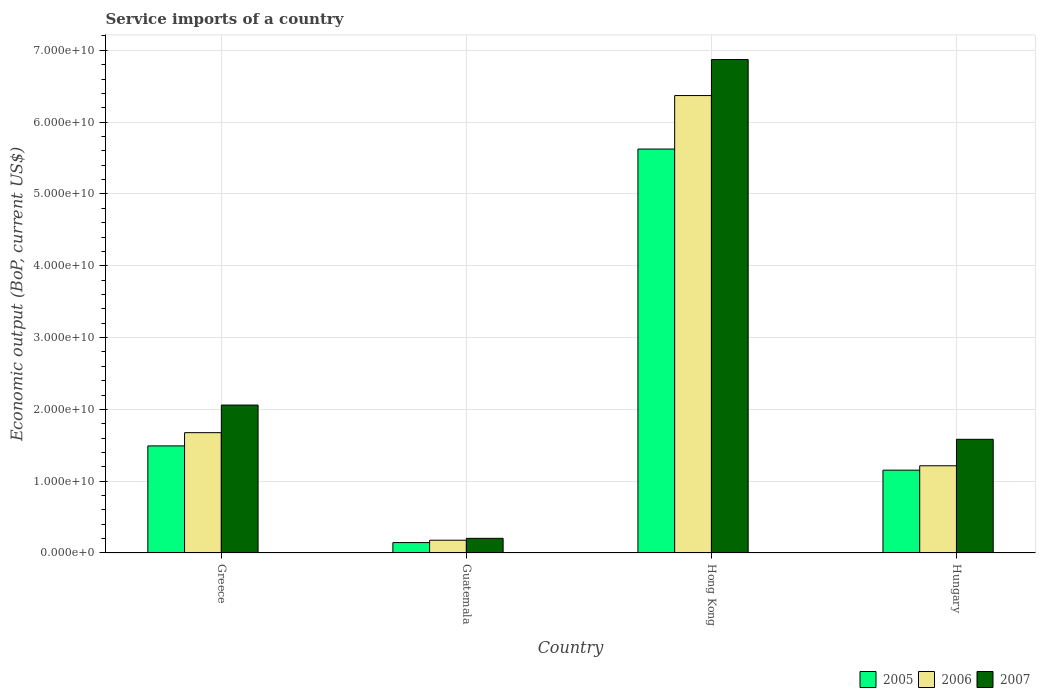Are the number of bars per tick equal to the number of legend labels?
Provide a short and direct response. Yes. Are the number of bars on each tick of the X-axis equal?
Make the answer very short. Yes. How many bars are there on the 4th tick from the left?
Ensure brevity in your answer.  3. In how many cases, is the number of bars for a given country not equal to the number of legend labels?
Offer a very short reply. 0. What is the service imports in 2006 in Hong Kong?
Make the answer very short. 6.37e+1. Across all countries, what is the maximum service imports in 2007?
Keep it short and to the point. 6.87e+1. Across all countries, what is the minimum service imports in 2005?
Provide a succinct answer. 1.45e+09. In which country was the service imports in 2007 maximum?
Offer a terse response. Hong Kong. In which country was the service imports in 2005 minimum?
Provide a succinct answer. Guatemala. What is the total service imports in 2005 in the graph?
Make the answer very short. 8.42e+1. What is the difference between the service imports in 2007 in Greece and that in Guatemala?
Provide a short and direct response. 1.86e+1. What is the difference between the service imports in 2005 in Guatemala and the service imports in 2007 in Hungary?
Offer a very short reply. -1.44e+1. What is the average service imports in 2005 per country?
Your answer should be very brief. 2.10e+1. What is the difference between the service imports of/in 2005 and service imports of/in 2007 in Guatemala?
Offer a very short reply. -5.92e+08. What is the ratio of the service imports in 2007 in Greece to that in Hong Kong?
Offer a very short reply. 0.3. Is the service imports in 2005 in Greece less than that in Hong Kong?
Give a very brief answer. Yes. Is the difference between the service imports in 2005 in Greece and Hong Kong greater than the difference between the service imports in 2007 in Greece and Hong Kong?
Keep it short and to the point. Yes. What is the difference between the highest and the second highest service imports in 2006?
Ensure brevity in your answer.  4.69e+1. What is the difference between the highest and the lowest service imports in 2005?
Your answer should be very brief. 5.48e+1. Is the sum of the service imports in 2007 in Hong Kong and Hungary greater than the maximum service imports in 2005 across all countries?
Give a very brief answer. Yes. What does the 3rd bar from the left in Greece represents?
Provide a short and direct response. 2007. Is it the case that in every country, the sum of the service imports in 2006 and service imports in 2005 is greater than the service imports in 2007?
Make the answer very short. Yes. How many bars are there?
Offer a terse response. 12. Are all the bars in the graph horizontal?
Offer a very short reply. No. How many countries are there in the graph?
Your answer should be very brief. 4. Does the graph contain any zero values?
Keep it short and to the point. No. What is the title of the graph?
Provide a short and direct response. Service imports of a country. Does "2009" appear as one of the legend labels in the graph?
Keep it short and to the point. No. What is the label or title of the Y-axis?
Keep it short and to the point. Economic output (BoP, current US$). What is the Economic output (BoP, current US$) of 2005 in Greece?
Provide a short and direct response. 1.49e+1. What is the Economic output (BoP, current US$) in 2006 in Greece?
Ensure brevity in your answer.  1.68e+1. What is the Economic output (BoP, current US$) in 2007 in Greece?
Provide a short and direct response. 2.06e+1. What is the Economic output (BoP, current US$) in 2005 in Guatemala?
Make the answer very short. 1.45e+09. What is the Economic output (BoP, current US$) of 2006 in Guatemala?
Ensure brevity in your answer.  1.78e+09. What is the Economic output (BoP, current US$) of 2007 in Guatemala?
Your response must be concise. 2.04e+09. What is the Economic output (BoP, current US$) of 2005 in Hong Kong?
Keep it short and to the point. 5.63e+1. What is the Economic output (BoP, current US$) in 2006 in Hong Kong?
Keep it short and to the point. 6.37e+1. What is the Economic output (BoP, current US$) of 2007 in Hong Kong?
Give a very brief answer. 6.87e+1. What is the Economic output (BoP, current US$) in 2005 in Hungary?
Make the answer very short. 1.15e+1. What is the Economic output (BoP, current US$) of 2006 in Hungary?
Offer a very short reply. 1.21e+1. What is the Economic output (BoP, current US$) of 2007 in Hungary?
Your answer should be compact. 1.58e+1. Across all countries, what is the maximum Economic output (BoP, current US$) of 2005?
Give a very brief answer. 5.63e+1. Across all countries, what is the maximum Economic output (BoP, current US$) in 2006?
Offer a very short reply. 6.37e+1. Across all countries, what is the maximum Economic output (BoP, current US$) in 2007?
Your response must be concise. 6.87e+1. Across all countries, what is the minimum Economic output (BoP, current US$) of 2005?
Your answer should be compact. 1.45e+09. Across all countries, what is the minimum Economic output (BoP, current US$) of 2006?
Ensure brevity in your answer.  1.78e+09. Across all countries, what is the minimum Economic output (BoP, current US$) of 2007?
Give a very brief answer. 2.04e+09. What is the total Economic output (BoP, current US$) of 2005 in the graph?
Make the answer very short. 8.42e+1. What is the total Economic output (BoP, current US$) of 2006 in the graph?
Provide a succinct answer. 9.44e+1. What is the total Economic output (BoP, current US$) in 2007 in the graph?
Your answer should be compact. 1.07e+11. What is the difference between the Economic output (BoP, current US$) in 2005 in Greece and that in Guatemala?
Offer a very short reply. 1.35e+1. What is the difference between the Economic output (BoP, current US$) in 2006 in Greece and that in Guatemala?
Your response must be concise. 1.50e+1. What is the difference between the Economic output (BoP, current US$) in 2007 in Greece and that in Guatemala?
Make the answer very short. 1.86e+1. What is the difference between the Economic output (BoP, current US$) of 2005 in Greece and that in Hong Kong?
Ensure brevity in your answer.  -4.13e+1. What is the difference between the Economic output (BoP, current US$) of 2006 in Greece and that in Hong Kong?
Ensure brevity in your answer.  -4.69e+1. What is the difference between the Economic output (BoP, current US$) of 2007 in Greece and that in Hong Kong?
Give a very brief answer. -4.81e+1. What is the difference between the Economic output (BoP, current US$) in 2005 in Greece and that in Hungary?
Keep it short and to the point. 3.38e+09. What is the difference between the Economic output (BoP, current US$) of 2006 in Greece and that in Hungary?
Offer a very short reply. 4.61e+09. What is the difference between the Economic output (BoP, current US$) in 2007 in Greece and that in Hungary?
Offer a very short reply. 4.77e+09. What is the difference between the Economic output (BoP, current US$) of 2005 in Guatemala and that in Hong Kong?
Give a very brief answer. -5.48e+1. What is the difference between the Economic output (BoP, current US$) in 2006 in Guatemala and that in Hong Kong?
Keep it short and to the point. -6.19e+1. What is the difference between the Economic output (BoP, current US$) of 2007 in Guatemala and that in Hong Kong?
Your answer should be very brief. -6.67e+1. What is the difference between the Economic output (BoP, current US$) of 2005 in Guatemala and that in Hungary?
Provide a short and direct response. -1.01e+1. What is the difference between the Economic output (BoP, current US$) of 2006 in Guatemala and that in Hungary?
Your answer should be very brief. -1.04e+1. What is the difference between the Economic output (BoP, current US$) of 2007 in Guatemala and that in Hungary?
Offer a very short reply. -1.38e+1. What is the difference between the Economic output (BoP, current US$) in 2005 in Hong Kong and that in Hungary?
Offer a very short reply. 4.47e+1. What is the difference between the Economic output (BoP, current US$) in 2006 in Hong Kong and that in Hungary?
Your answer should be compact. 5.16e+1. What is the difference between the Economic output (BoP, current US$) of 2007 in Hong Kong and that in Hungary?
Provide a short and direct response. 5.29e+1. What is the difference between the Economic output (BoP, current US$) of 2005 in Greece and the Economic output (BoP, current US$) of 2006 in Guatemala?
Provide a short and direct response. 1.31e+1. What is the difference between the Economic output (BoP, current US$) of 2005 in Greece and the Economic output (BoP, current US$) of 2007 in Guatemala?
Give a very brief answer. 1.29e+1. What is the difference between the Economic output (BoP, current US$) in 2006 in Greece and the Economic output (BoP, current US$) in 2007 in Guatemala?
Your answer should be very brief. 1.47e+1. What is the difference between the Economic output (BoP, current US$) of 2005 in Greece and the Economic output (BoP, current US$) of 2006 in Hong Kong?
Ensure brevity in your answer.  -4.88e+1. What is the difference between the Economic output (BoP, current US$) of 2005 in Greece and the Economic output (BoP, current US$) of 2007 in Hong Kong?
Keep it short and to the point. -5.38e+1. What is the difference between the Economic output (BoP, current US$) of 2006 in Greece and the Economic output (BoP, current US$) of 2007 in Hong Kong?
Offer a terse response. -5.20e+1. What is the difference between the Economic output (BoP, current US$) of 2005 in Greece and the Economic output (BoP, current US$) of 2006 in Hungary?
Your response must be concise. 2.77e+09. What is the difference between the Economic output (BoP, current US$) of 2005 in Greece and the Economic output (BoP, current US$) of 2007 in Hungary?
Offer a very short reply. -9.18e+08. What is the difference between the Economic output (BoP, current US$) in 2006 in Greece and the Economic output (BoP, current US$) in 2007 in Hungary?
Offer a terse response. 9.25e+08. What is the difference between the Economic output (BoP, current US$) in 2005 in Guatemala and the Economic output (BoP, current US$) in 2006 in Hong Kong?
Your answer should be compact. -6.23e+1. What is the difference between the Economic output (BoP, current US$) in 2005 in Guatemala and the Economic output (BoP, current US$) in 2007 in Hong Kong?
Offer a very short reply. -6.73e+1. What is the difference between the Economic output (BoP, current US$) of 2006 in Guatemala and the Economic output (BoP, current US$) of 2007 in Hong Kong?
Make the answer very short. -6.69e+1. What is the difference between the Economic output (BoP, current US$) in 2005 in Guatemala and the Economic output (BoP, current US$) in 2006 in Hungary?
Provide a succinct answer. -1.07e+1. What is the difference between the Economic output (BoP, current US$) of 2005 in Guatemala and the Economic output (BoP, current US$) of 2007 in Hungary?
Provide a short and direct response. -1.44e+1. What is the difference between the Economic output (BoP, current US$) in 2006 in Guatemala and the Economic output (BoP, current US$) in 2007 in Hungary?
Your answer should be compact. -1.41e+1. What is the difference between the Economic output (BoP, current US$) in 2005 in Hong Kong and the Economic output (BoP, current US$) in 2006 in Hungary?
Provide a succinct answer. 4.41e+1. What is the difference between the Economic output (BoP, current US$) in 2005 in Hong Kong and the Economic output (BoP, current US$) in 2007 in Hungary?
Ensure brevity in your answer.  4.04e+1. What is the difference between the Economic output (BoP, current US$) in 2006 in Hong Kong and the Economic output (BoP, current US$) in 2007 in Hungary?
Offer a very short reply. 4.79e+1. What is the average Economic output (BoP, current US$) in 2005 per country?
Your answer should be very brief. 2.10e+1. What is the average Economic output (BoP, current US$) in 2006 per country?
Offer a very short reply. 2.36e+1. What is the average Economic output (BoP, current US$) of 2007 per country?
Ensure brevity in your answer.  2.68e+1. What is the difference between the Economic output (BoP, current US$) in 2005 and Economic output (BoP, current US$) in 2006 in Greece?
Offer a terse response. -1.84e+09. What is the difference between the Economic output (BoP, current US$) in 2005 and Economic output (BoP, current US$) in 2007 in Greece?
Provide a short and direct response. -5.69e+09. What is the difference between the Economic output (BoP, current US$) of 2006 and Economic output (BoP, current US$) of 2007 in Greece?
Keep it short and to the point. -3.85e+09. What is the difference between the Economic output (BoP, current US$) in 2005 and Economic output (BoP, current US$) in 2006 in Guatemala?
Offer a terse response. -3.29e+08. What is the difference between the Economic output (BoP, current US$) in 2005 and Economic output (BoP, current US$) in 2007 in Guatemala?
Offer a very short reply. -5.92e+08. What is the difference between the Economic output (BoP, current US$) in 2006 and Economic output (BoP, current US$) in 2007 in Guatemala?
Provide a succinct answer. -2.63e+08. What is the difference between the Economic output (BoP, current US$) of 2005 and Economic output (BoP, current US$) of 2006 in Hong Kong?
Offer a terse response. -7.45e+09. What is the difference between the Economic output (BoP, current US$) in 2005 and Economic output (BoP, current US$) in 2007 in Hong Kong?
Keep it short and to the point. -1.25e+1. What is the difference between the Economic output (BoP, current US$) of 2006 and Economic output (BoP, current US$) of 2007 in Hong Kong?
Keep it short and to the point. -5.01e+09. What is the difference between the Economic output (BoP, current US$) in 2005 and Economic output (BoP, current US$) in 2006 in Hungary?
Give a very brief answer. -6.10e+08. What is the difference between the Economic output (BoP, current US$) in 2005 and Economic output (BoP, current US$) in 2007 in Hungary?
Ensure brevity in your answer.  -4.30e+09. What is the difference between the Economic output (BoP, current US$) of 2006 and Economic output (BoP, current US$) of 2007 in Hungary?
Keep it short and to the point. -3.69e+09. What is the ratio of the Economic output (BoP, current US$) of 2005 in Greece to that in Guatemala?
Offer a very short reply. 10.29. What is the ratio of the Economic output (BoP, current US$) of 2006 in Greece to that in Guatemala?
Give a very brief answer. 9.42. What is the ratio of the Economic output (BoP, current US$) in 2007 in Greece to that in Guatemala?
Your response must be concise. 10.09. What is the ratio of the Economic output (BoP, current US$) in 2005 in Greece to that in Hong Kong?
Keep it short and to the point. 0.27. What is the ratio of the Economic output (BoP, current US$) of 2006 in Greece to that in Hong Kong?
Your answer should be compact. 0.26. What is the ratio of the Economic output (BoP, current US$) in 2007 in Greece to that in Hong Kong?
Your answer should be compact. 0.3. What is the ratio of the Economic output (BoP, current US$) of 2005 in Greece to that in Hungary?
Offer a terse response. 1.29. What is the ratio of the Economic output (BoP, current US$) of 2006 in Greece to that in Hungary?
Give a very brief answer. 1.38. What is the ratio of the Economic output (BoP, current US$) of 2007 in Greece to that in Hungary?
Provide a succinct answer. 1.3. What is the ratio of the Economic output (BoP, current US$) in 2005 in Guatemala to that in Hong Kong?
Provide a succinct answer. 0.03. What is the ratio of the Economic output (BoP, current US$) in 2006 in Guatemala to that in Hong Kong?
Your answer should be compact. 0.03. What is the ratio of the Economic output (BoP, current US$) in 2007 in Guatemala to that in Hong Kong?
Provide a short and direct response. 0.03. What is the ratio of the Economic output (BoP, current US$) in 2005 in Guatemala to that in Hungary?
Keep it short and to the point. 0.13. What is the ratio of the Economic output (BoP, current US$) in 2006 in Guatemala to that in Hungary?
Offer a terse response. 0.15. What is the ratio of the Economic output (BoP, current US$) in 2007 in Guatemala to that in Hungary?
Your answer should be compact. 0.13. What is the ratio of the Economic output (BoP, current US$) in 2005 in Hong Kong to that in Hungary?
Ensure brevity in your answer.  4.88. What is the ratio of the Economic output (BoP, current US$) of 2006 in Hong Kong to that in Hungary?
Provide a succinct answer. 5.25. What is the ratio of the Economic output (BoP, current US$) in 2007 in Hong Kong to that in Hungary?
Give a very brief answer. 4.34. What is the difference between the highest and the second highest Economic output (BoP, current US$) in 2005?
Your answer should be very brief. 4.13e+1. What is the difference between the highest and the second highest Economic output (BoP, current US$) in 2006?
Ensure brevity in your answer.  4.69e+1. What is the difference between the highest and the second highest Economic output (BoP, current US$) of 2007?
Ensure brevity in your answer.  4.81e+1. What is the difference between the highest and the lowest Economic output (BoP, current US$) of 2005?
Keep it short and to the point. 5.48e+1. What is the difference between the highest and the lowest Economic output (BoP, current US$) of 2006?
Ensure brevity in your answer.  6.19e+1. What is the difference between the highest and the lowest Economic output (BoP, current US$) in 2007?
Provide a succinct answer. 6.67e+1. 